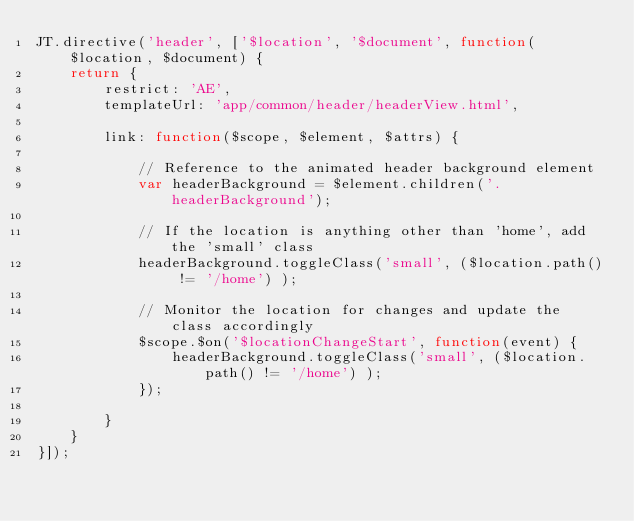<code> <loc_0><loc_0><loc_500><loc_500><_JavaScript_>JT.directive('header', ['$location', '$document', function($location, $document) {
	return {
		restrict: 'AE',
		templateUrl: 'app/common/header/headerView.html',

		link: function($scope, $element, $attrs) {

			// Reference to the animated header background element
			var headerBackground = $element.children('.headerBackground');

			// If the location is anything other than 'home', add the 'small' class
			headerBackground.toggleClass('small', ($location.path() != '/home') );

			// Monitor the location for changes and update the class accordingly
			$scope.$on('$locationChangeStart', function(event) {
				headerBackground.toggleClass('small', ($location.path() != '/home') );
			});

		}
	}
}]);</code> 